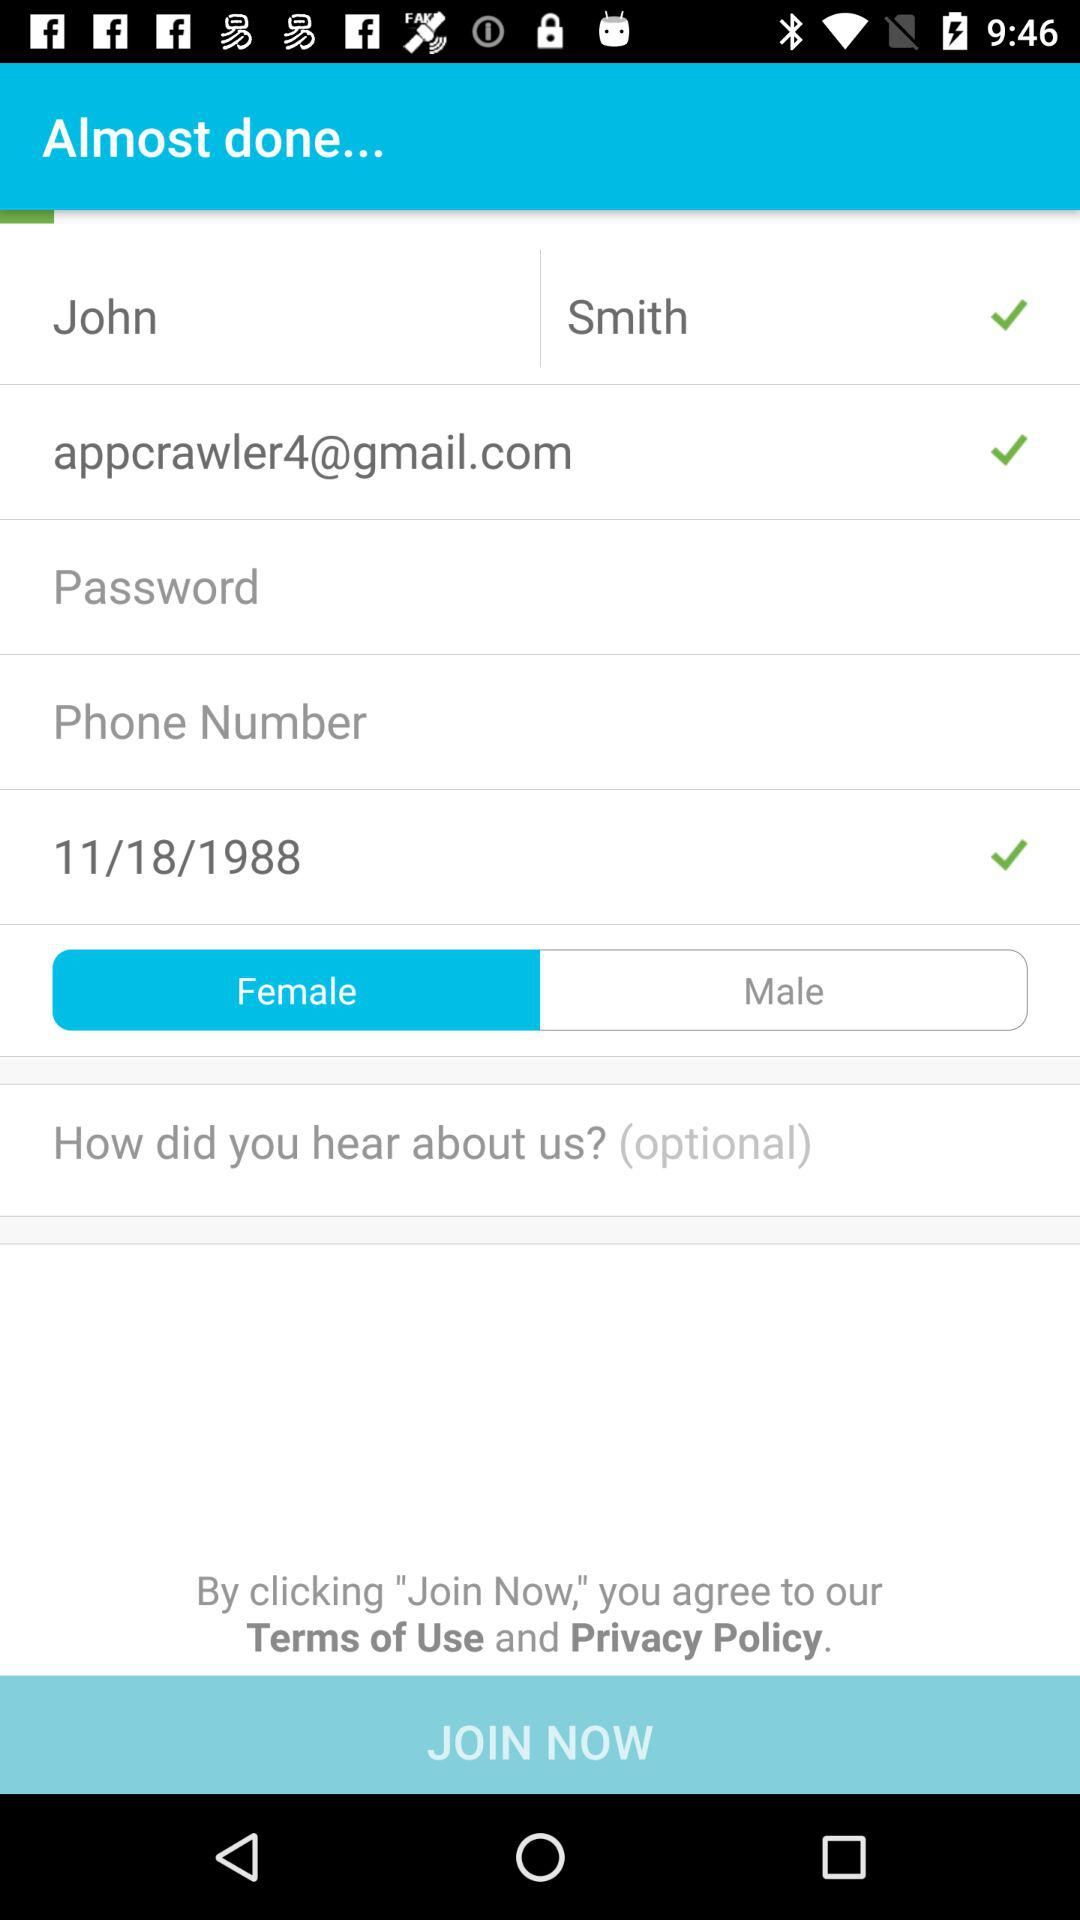Which gender is selected? The selected gender is female. 